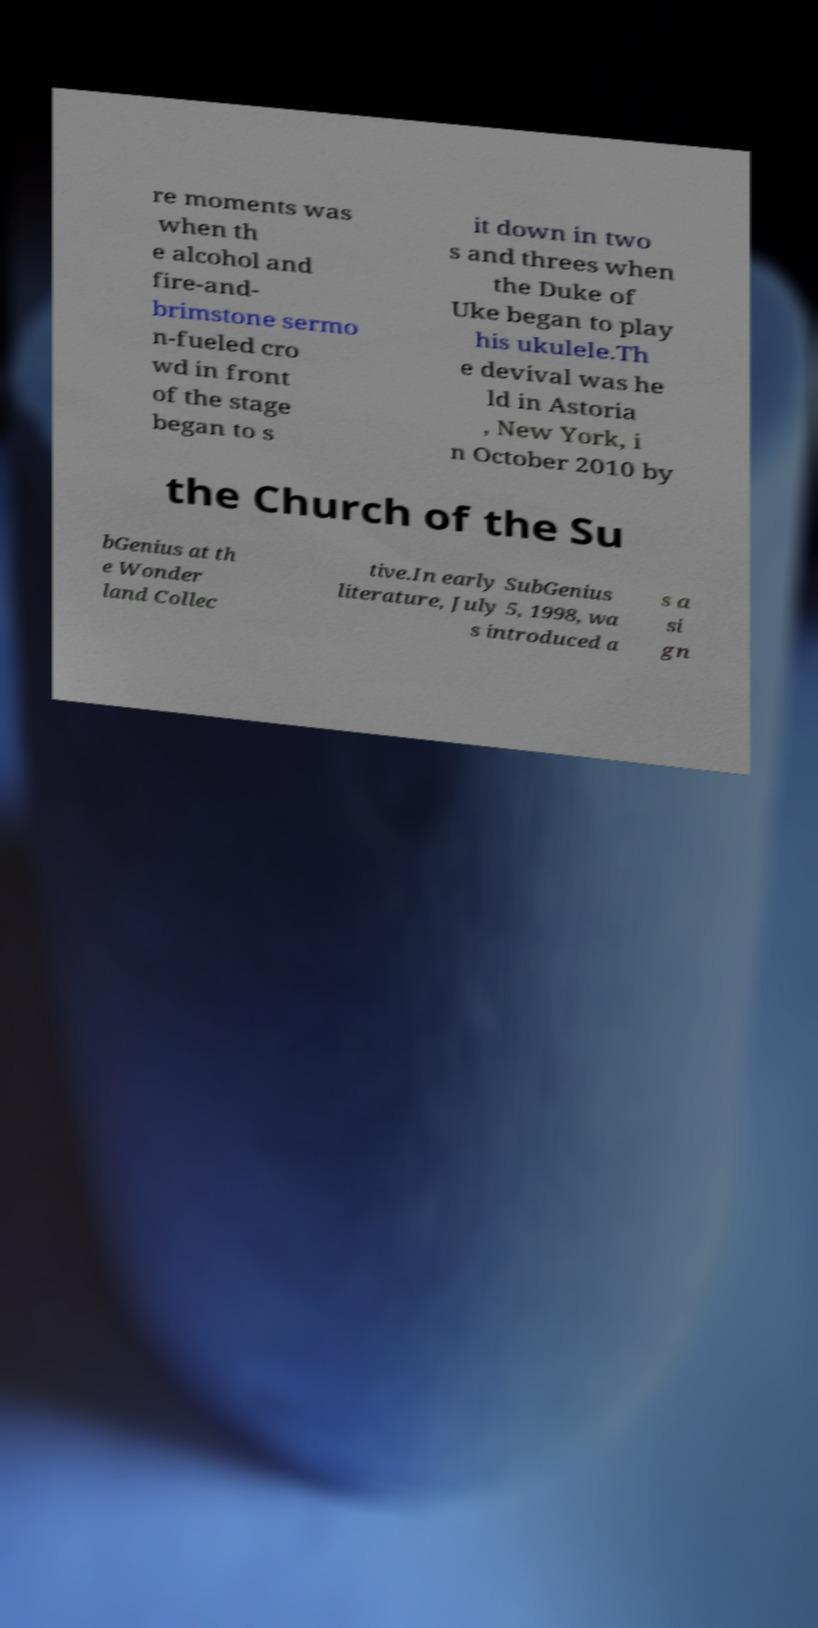Please read and relay the text visible in this image. What does it say? re moments was when th e alcohol and fire-and- brimstone sermo n-fueled cro wd in front of the stage began to s it down in two s and threes when the Duke of Uke began to play his ukulele.Th e devival was he ld in Astoria , New York, i n October 2010 by the Church of the Su bGenius at th e Wonder land Collec tive.In early SubGenius literature, July 5, 1998, wa s introduced a s a si gn 